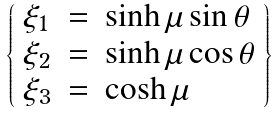<formula> <loc_0><loc_0><loc_500><loc_500>\left \{ \begin{array} { l l l } \xi _ { 1 } & = & \sinh \mu \sin \theta \\ \xi _ { 2 } & = & \sinh \mu \cos \theta \\ \xi _ { 3 } & = & \cosh \mu \end{array} \right \}</formula> 